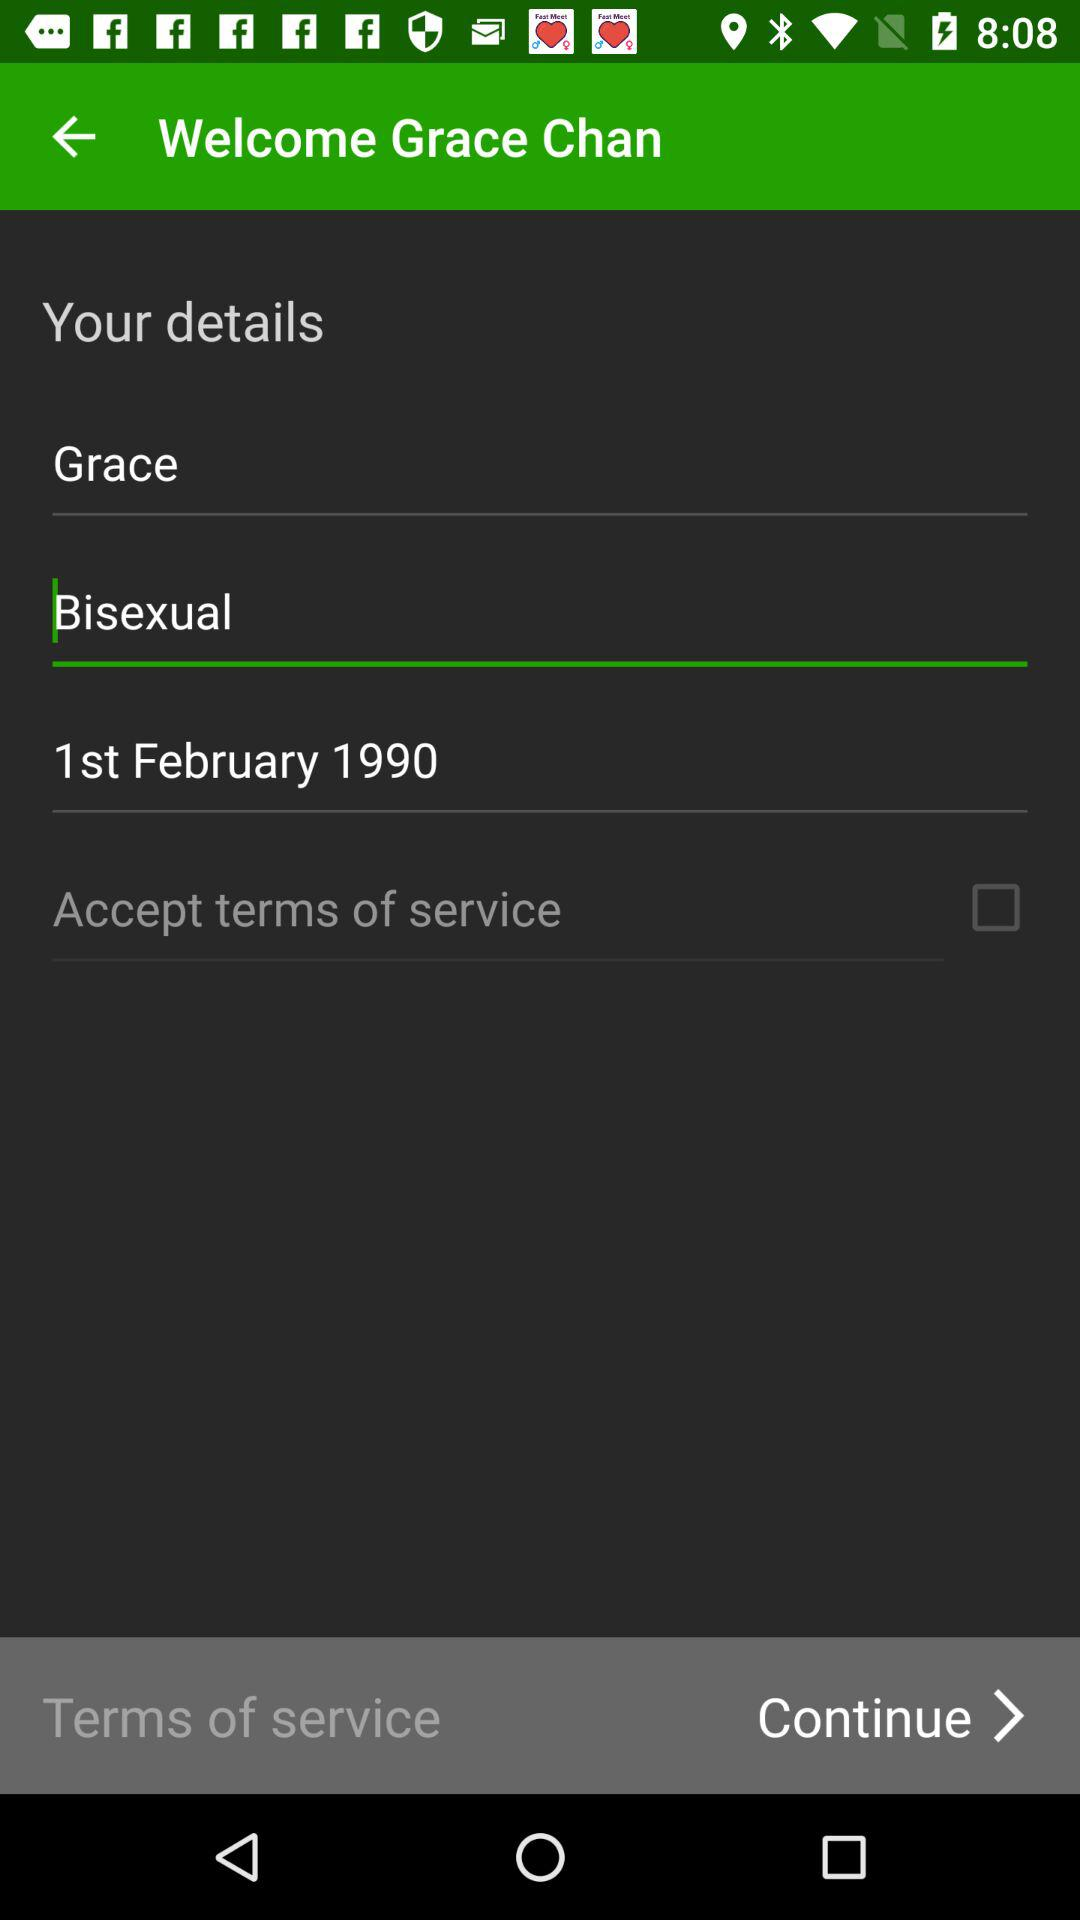How many text inputs are not empty?
Answer the question using a single word or phrase. 3 